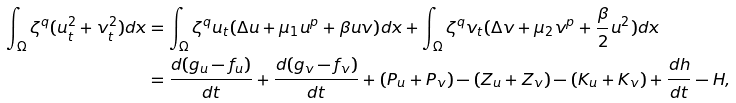Convert formula to latex. <formula><loc_0><loc_0><loc_500><loc_500>\int _ { \Omega } \zeta ^ { q } ( u _ { t } ^ { 2 } + v _ { t } ^ { 2 } ) d x & = \int _ { \Omega } \zeta ^ { q } u _ { t } ( \Delta u + \mu _ { 1 } u ^ { p } + \beta u v ) d x + \int _ { \Omega } \zeta ^ { q } v _ { t } ( \Delta v + \mu _ { 2 } v ^ { p } + \frac { \beta } { 2 } u ^ { 2 } ) d x \\ & = \frac { d ( g _ { u } - f _ { u } ) } { d t } + \frac { d ( g _ { v } - f _ { v } ) } { d t } + ( P _ { u } + P _ { v } ) - ( Z _ { u } + Z _ { v } ) - ( K _ { u } + K _ { v } ) + \frac { d h } { d t } - H ,</formula> 